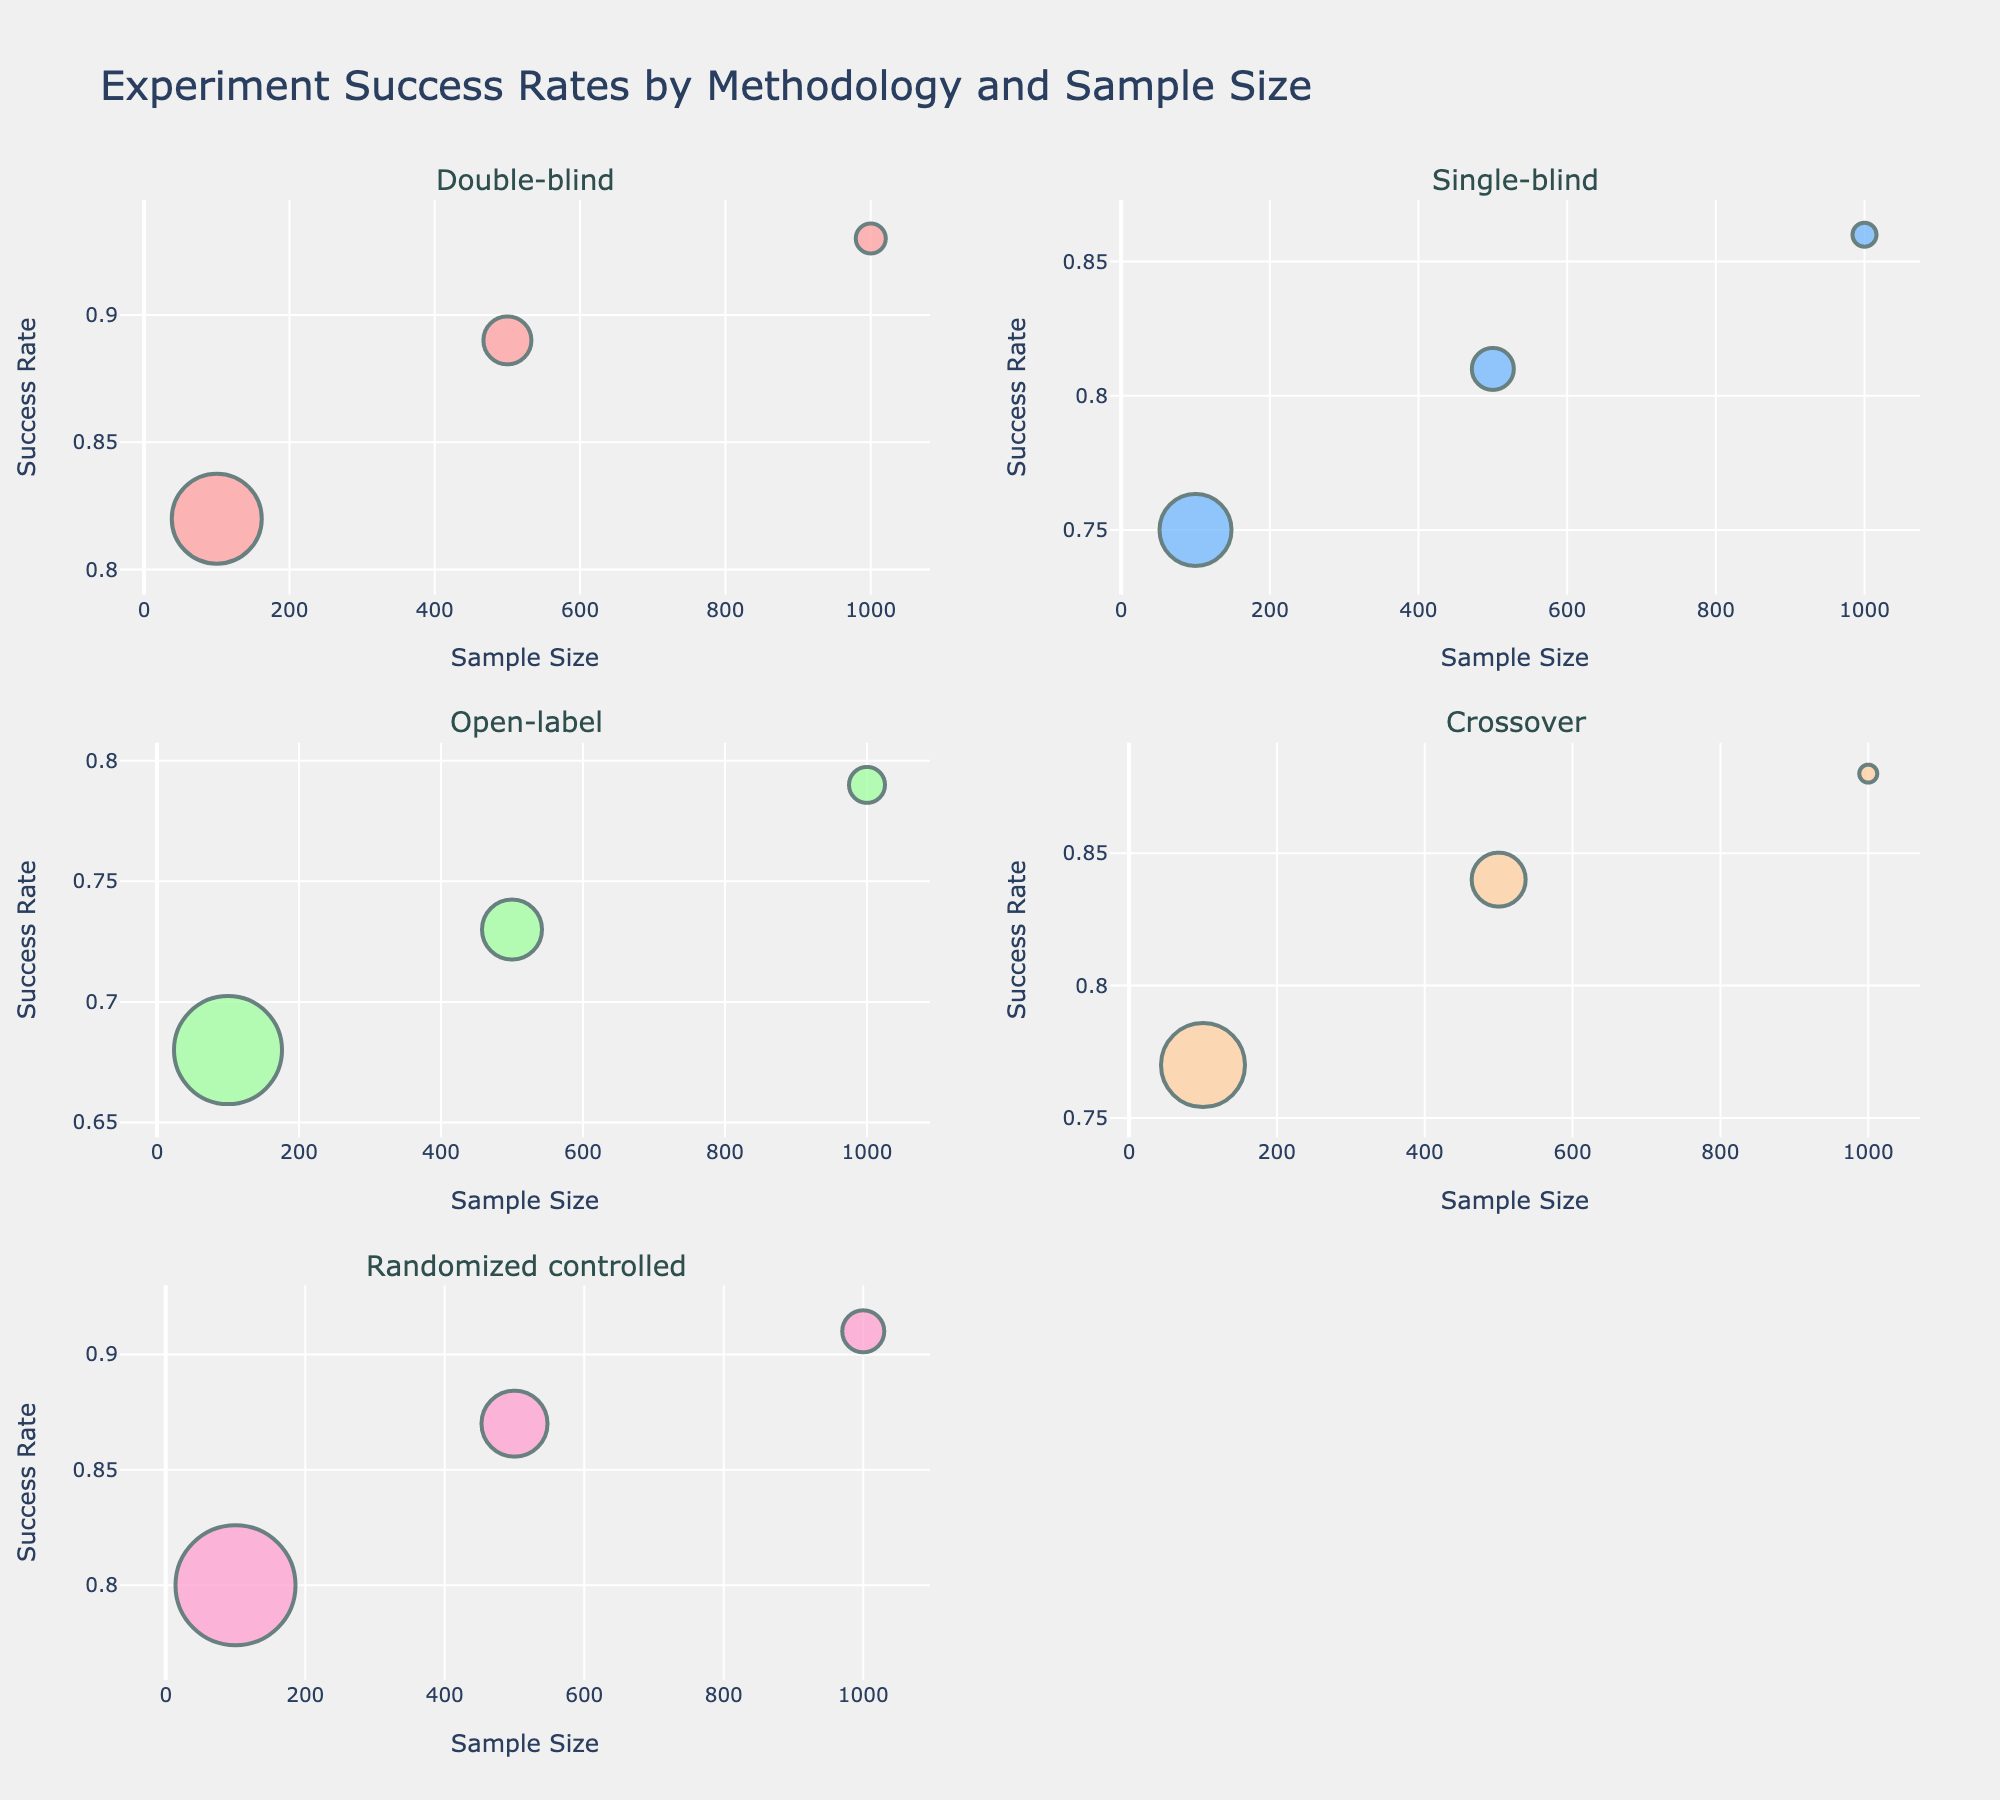What is the main title of the figure? The main title of the figure is positioned at the top, summarizing what the plot is about.
Answer: Experiment Success Rates by Methodology and Sample Size Which methodology has the highest success rate? Look at the highest value on the y-axis (Success Rate) for each subplot, and identify the methodology corresponding to the subplot with the highest value.
Answer: Double-blind How does the success rate vary with sample size for the Single-blind methodology? Examine the bubbles in the subplot for Single-blind methodology. Notice the trend as you move from sample size 100 to 1000 on the x-axis. The success rate increases: 0.75 (100), 0.81 (500), 0.86 (1000).
Answer: Increases Which methodology has the most studies conducted with a sample size of 100? Identify which subplot has the largest bubble corresponding to x-axis value 100. Larger bubbles indicate more studies.
Answer: Randomized controlled What is the difference in success rate between the Open-label methodology at sample sizes 500 and 1000? Check the success rates for Open-label methodology at sample sizes of 500 and 1000. The values are 0.73 and 0.79 respectively. Calculate the difference: 0.79 - 0.73.
Answer: 0.06 At what sample size does the Crossover methodology have the highest success rate? Observe the y-axis values for each sample size within the Crossover subplot. The highest y-axis value indicates the highest success rate.
Answer: 1000 What is the average success rate for the Randomized controlled methodology across all sample sizes? Add the success rates for Randomized controlled methodology (0.80, 0.87, 0.91), then divide by the number of sample sizes (3). (0.80 + 0.87 + 0.91) / 3 = 0.86
Answer: 0.86 Which methodology demonstrates the smallest increase in success rate with increasing sample size? Compare the differences in success rates from smallest to largest sample sizes across all methodologies. For each methodology, note the success rate change and identify the smallest. Single-blind: (0.86 - 0.75 = 0.11), Open-label: (0.79 - 0.68 = 0.11), Double-blind: (0.93 - 0.82 = 0.11), Crossover: (0.88 - 0.77 = 0.11), Randomized controlled: (0.91 - 0.80 = 0.11). If changes are the same, any can be chosen.
Answer: Any methodology Which methodology has the most varied success rates? Identify the methodology whose success rates span the largest range from its minimum to maximum values. Calculate the range for each methodology: Open-label: (0.68 to 0.79 = 0.11), Single-blind: (0.75 to 0.86 = 0.11), Double-blind: (0.82 to 0.93 = 0.11), Crossover: (0.77 to 0.88 = 0.11), Randomized controlled: (0.80 to 0.91 = 0.11). If ranges are the same, any can be chosen.
Answer: Any methodology What is the total number of studies conducted across all methodologies with sample sizes of 500? Sum the study counts for all methodologies at the sample size 500: Double-blind (8), Single-blind (7), Open-label (10), Crossover (9), Randomized controlled (11). Total = 8 + 7 + 10 + 9 + 11 = 45
Answer: 45 